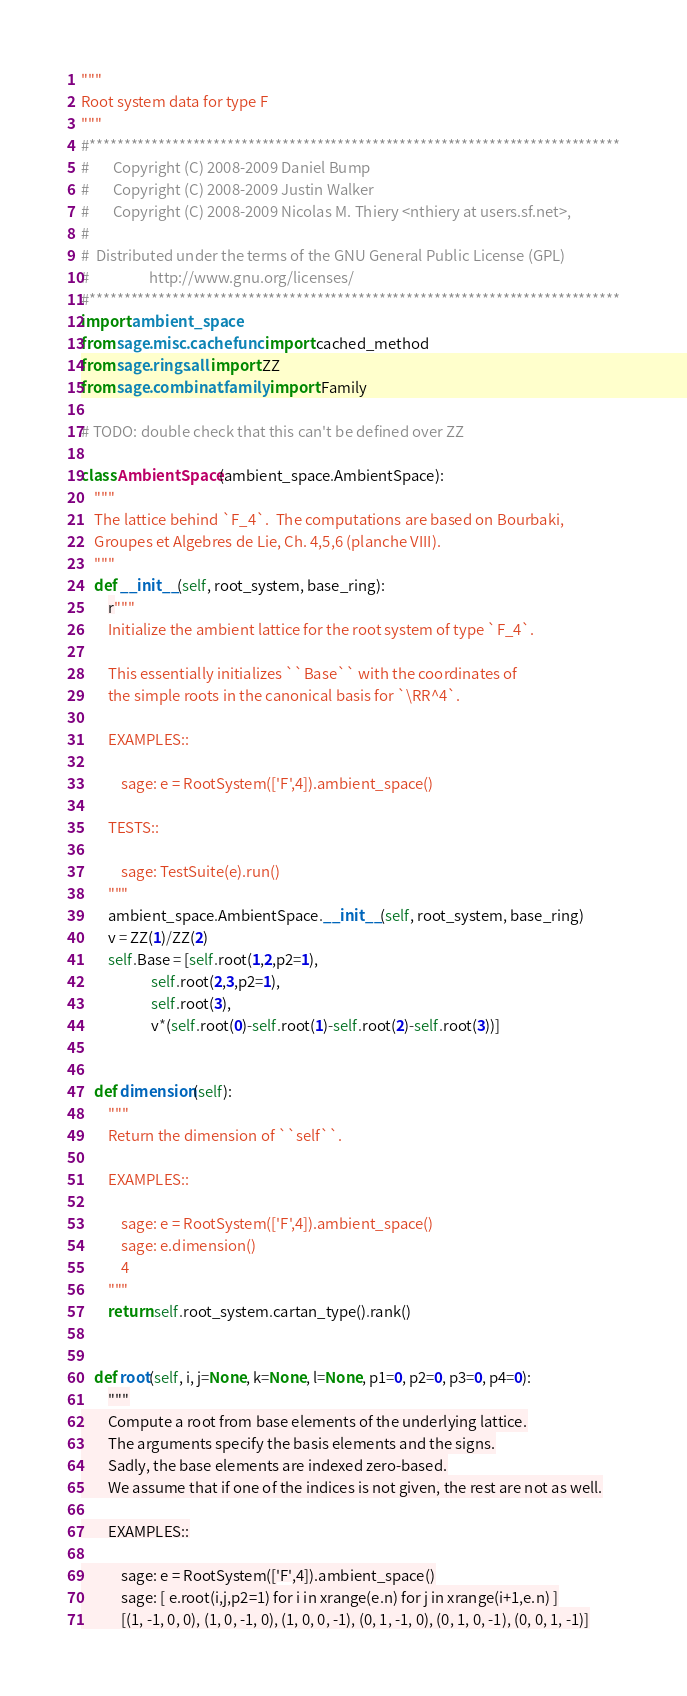<code> <loc_0><loc_0><loc_500><loc_500><_Python_>"""
Root system data for type F
"""
#*****************************************************************************
#       Copyright (C) 2008-2009 Daniel Bump
#       Copyright (C) 2008-2009 Justin Walker
#       Copyright (C) 2008-2009 Nicolas M. Thiery <nthiery at users.sf.net>,
#
#  Distributed under the terms of the GNU General Public License (GPL)
#                  http://www.gnu.org/licenses/
#*****************************************************************************
import ambient_space
from sage.misc.cachefunc import cached_method
from sage.rings.all import ZZ
from sage.combinat.family import Family

# TODO: double check that this can't be defined over ZZ

class AmbientSpace(ambient_space.AmbientSpace):
    """
    The lattice behind `F_4`.  The computations are based on Bourbaki,
    Groupes et Algebres de Lie, Ch. 4,5,6 (planche VIII).
    """
    def __init__(self, root_system, base_ring):
        r"""
        Initialize the ambient lattice for the root system of type `F_4`.

        This essentially initializes ``Base`` with the coordinates of
        the simple roots in the canonical basis for `\RR^4`.

        EXAMPLES::

            sage: e = RootSystem(['F',4]).ambient_space()

        TESTS::

            sage: TestSuite(e).run()
        """
        ambient_space.AmbientSpace.__init__(self, root_system, base_ring)
        v = ZZ(1)/ZZ(2)
        self.Base = [self.root(1,2,p2=1),
                     self.root(2,3,p2=1),
                     self.root(3),
                     v*(self.root(0)-self.root(1)-self.root(2)-self.root(3))]


    def dimension(self):
        """
        Return the dimension of ``self``.

        EXAMPLES::

            sage: e = RootSystem(['F',4]).ambient_space()
            sage: e.dimension()
            4
        """
        return self.root_system.cartan_type().rank()


    def root(self, i, j=None, k=None, l=None, p1=0, p2=0, p3=0, p4=0):
        """
        Compute a root from base elements of the underlying lattice.
        The arguments specify the basis elements and the signs.
        Sadly, the base elements are indexed zero-based.
        We assume that if one of the indices is not given, the rest are not as well.

        EXAMPLES::

            sage: e = RootSystem(['F',4]).ambient_space()
            sage: [ e.root(i,j,p2=1) for i in xrange(e.n) for j in xrange(i+1,e.n) ]
            [(1, -1, 0, 0), (1, 0, -1, 0), (1, 0, 0, -1), (0, 1, -1, 0), (0, 1, 0, -1), (0, 0, 1, -1)]</code> 